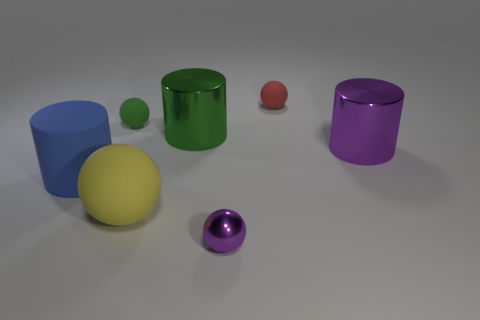Add 3 purple things. How many objects exist? 10 Subtract all balls. How many objects are left? 3 Add 2 blue rubber cylinders. How many blue rubber cylinders are left? 3 Add 5 matte cylinders. How many matte cylinders exist? 6 Subtract 1 green spheres. How many objects are left? 6 Subtract all spheres. Subtract all tiny red matte things. How many objects are left? 2 